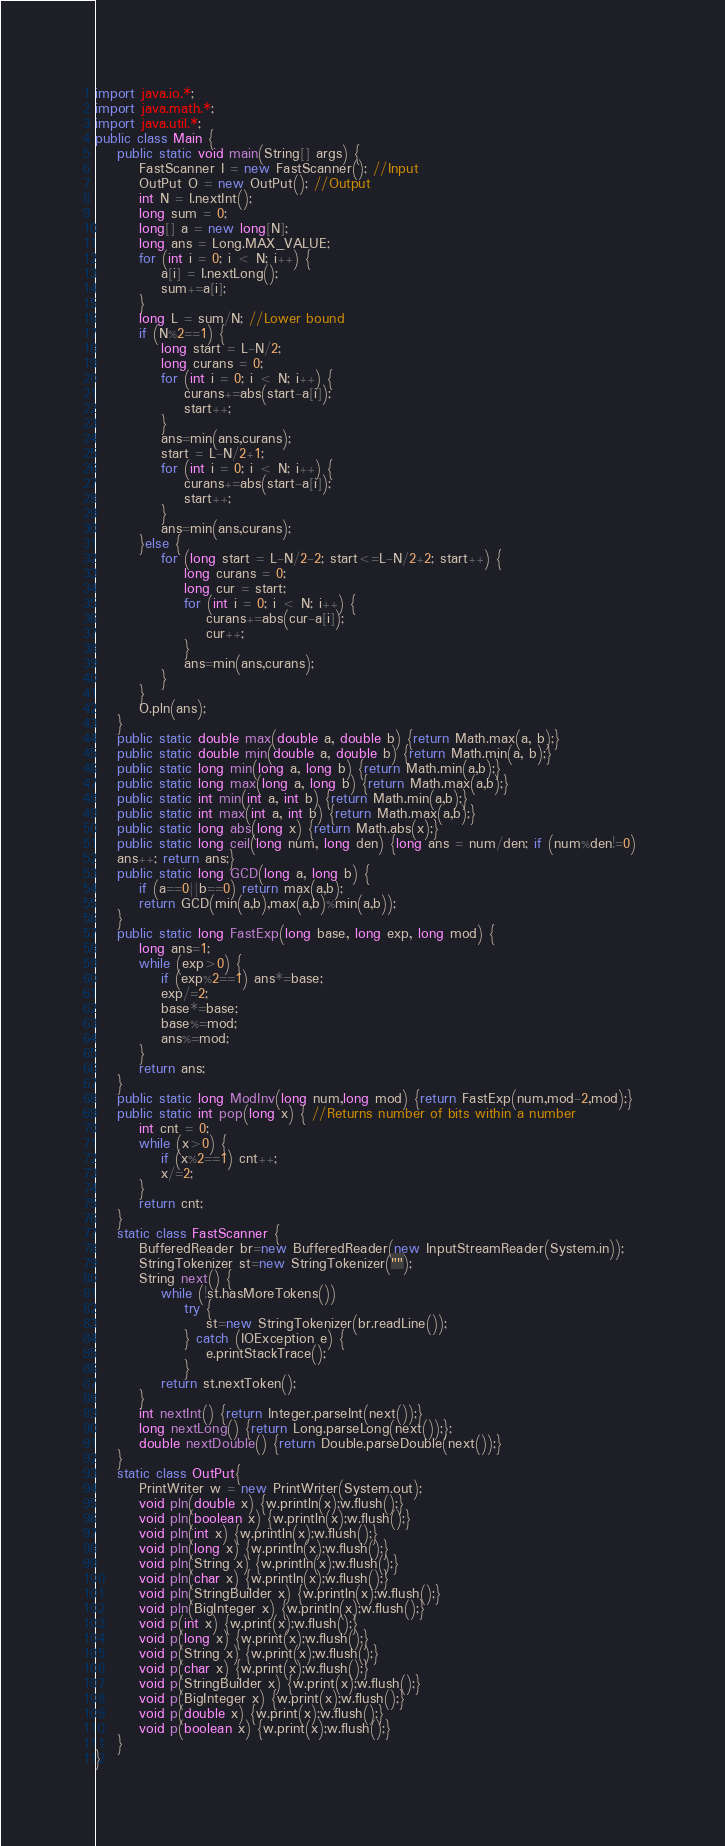Convert code to text. <code><loc_0><loc_0><loc_500><loc_500><_Java_>import java.io.*;
import java.math.*;
import java.util.*;
public class Main {
	public static void main(String[] args) {  
		FastScanner I = new FastScanner(); //Input
		OutPut O = new OutPut(); //Output
		int N = I.nextInt();
		long sum = 0;
		long[] a = new long[N];
		long ans = Long.MAX_VALUE;
		for (int i = 0; i < N; i++) {
			a[i] = I.nextLong();
			sum+=a[i];
		}
		long L = sum/N; //Lower bound
		if (N%2==1) {
			long start = L-N/2;
			long curans = 0;
			for (int i = 0; i < N; i++) {
				curans+=abs(start-a[i]);
				start++;
			}
			ans=min(ans,curans);
			start = L-N/2+1;
			for (int i = 0; i < N; i++) {
				curans+=abs(start-a[i]);
				start++;
			}
			ans=min(ans,curans);
		}else {
			for (long start = L-N/2-2; start<=L-N/2+2; start++) {
				long curans = 0;
				long cur = start;
				for (int i = 0; i < N; i++) {
					curans+=abs(cur-a[i]);
					cur++;
				}
				ans=min(ans,curans);
			}
		}
		O.pln(ans);
	}
	public static double max(double a, double b) {return Math.max(a, b);}
	public static double min(double a, double b) {return Math.min(a, b);}
	public static long min(long a, long b) {return Math.min(a,b);}
	public static long max(long a, long b) {return Math.max(a,b);}
	public static int min(int a, int b) {return Math.min(a,b);}
	public static int max(int a, int b) {return Math.max(a,b);}
	public static long abs(long x) {return Math.abs(x);}
	public static long ceil(long num, long den) {long ans = num/den; if (num%den!=0) 
	ans++; return ans;}
	public static long GCD(long a, long b) {
		if (a==0||b==0) return max(a,b);
		return GCD(min(a,b),max(a,b)%min(a,b));
	}
	public static long FastExp(long base, long exp, long mod) {
		long ans=1;
		while (exp>0) {
			if (exp%2==1) ans*=base;
			exp/=2;
			base*=base;
			base%=mod;
			ans%=mod;
		}
		return ans;
	}
	public static long ModInv(long num,long mod) {return FastExp(num,mod-2,mod);}
	public static int pop(long x) { //Returns number of bits within a number
		int cnt = 0;
		while (x>0) {
			if (x%2==1) cnt++;
			x/=2;
		}
		return cnt;
	}
	static class FastScanner {
		BufferedReader br=new BufferedReader(new InputStreamReader(System.in));
		StringTokenizer st=new StringTokenizer("");
		String next() {
			while (!st.hasMoreTokens())
				try {
					st=new StringTokenizer(br.readLine());
				} catch (IOException e) {
					e.printStackTrace();
				}
			return st.nextToken();
		}
		int nextInt() {return Integer.parseInt(next());}
		long nextLong() {return Long.parseLong(next());};
		double nextDouble() {return Double.parseDouble(next());}
	}
	static class OutPut{
		PrintWriter w = new PrintWriter(System.out);
		void pln(double x) {w.println(x);w.flush();}
		void pln(boolean x) {w.println(x);w.flush();}
		void pln(int x) {w.println(x);w.flush();}
		void pln(long x) {w.println(x);w.flush();}
		void pln(String x) {w.println(x);w.flush();}
		void pln(char x) {w.println(x);w.flush();}
		void pln(StringBuilder x) {w.println(x);w.flush();}
		void pln(BigInteger x) {w.println(x);w.flush();}
		void p(int x) {w.print(x);w.flush();}
		void p(long x) {w.print(x);w.flush();}
		void p(String x) {w.print(x);w.flush();}
		void p(char x) {w.print(x);w.flush();}
		void p(StringBuilder x) {w.print(x);w.flush();}
		void p(BigInteger x) {w.print(x);w.flush();}
		void p(double x) {w.print(x);w.flush();}
		void p(boolean x) {w.print(x);w.flush();}
	}
}
</code> 